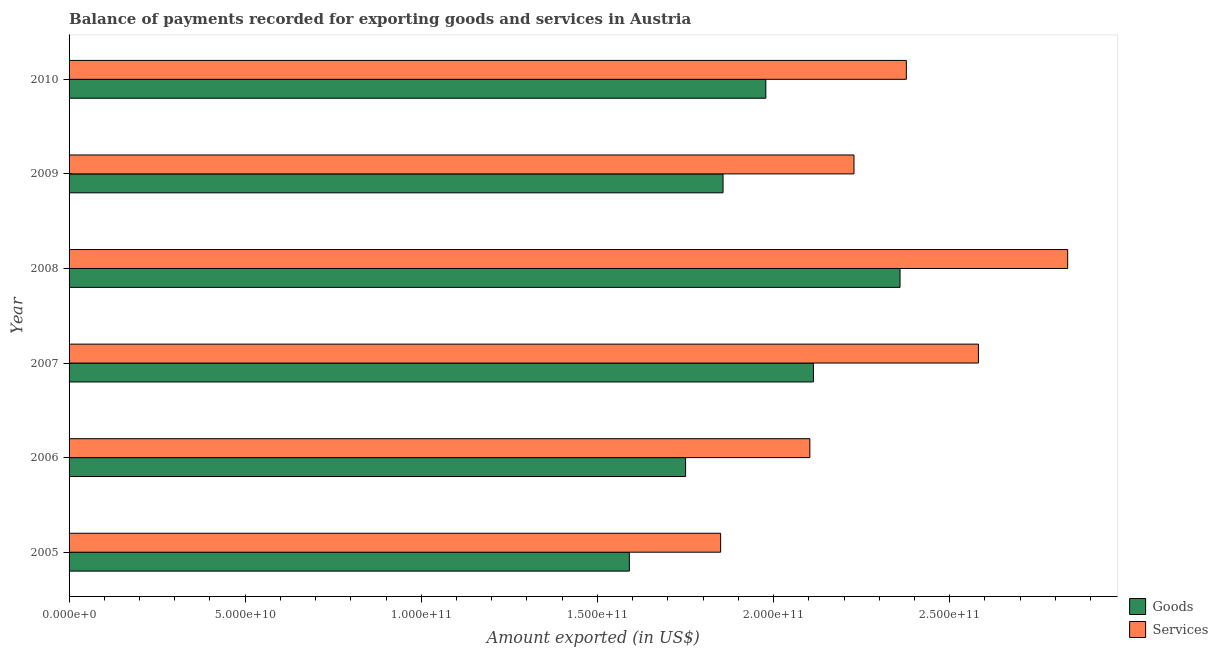How many groups of bars are there?
Provide a succinct answer. 6. Are the number of bars on each tick of the Y-axis equal?
Ensure brevity in your answer.  Yes. How many bars are there on the 2nd tick from the top?
Provide a succinct answer. 2. How many bars are there on the 2nd tick from the bottom?
Your answer should be compact. 2. What is the label of the 4th group of bars from the top?
Your answer should be very brief. 2007. What is the amount of services exported in 2005?
Your answer should be compact. 1.85e+11. Across all years, what is the maximum amount of services exported?
Provide a short and direct response. 2.83e+11. Across all years, what is the minimum amount of goods exported?
Provide a short and direct response. 1.59e+11. In which year was the amount of goods exported maximum?
Provide a succinct answer. 2008. What is the total amount of services exported in the graph?
Your answer should be compact. 1.40e+12. What is the difference between the amount of services exported in 2007 and that in 2008?
Keep it short and to the point. -2.53e+1. What is the difference between the amount of goods exported in 2006 and the amount of services exported in 2007?
Offer a terse response. -8.31e+1. What is the average amount of goods exported per year?
Make the answer very short. 1.94e+11. In the year 2009, what is the difference between the amount of services exported and amount of goods exported?
Provide a short and direct response. 3.72e+1. In how many years, is the amount of goods exported greater than 70000000000 US$?
Provide a short and direct response. 6. What is the ratio of the amount of goods exported in 2005 to that in 2007?
Make the answer very short. 0.75. Is the difference between the amount of goods exported in 2006 and 2008 greater than the difference between the amount of services exported in 2006 and 2008?
Provide a succinct answer. Yes. What is the difference between the highest and the second highest amount of goods exported?
Offer a terse response. 2.46e+1. What is the difference between the highest and the lowest amount of services exported?
Offer a terse response. 9.85e+1. Is the sum of the amount of services exported in 2009 and 2010 greater than the maximum amount of goods exported across all years?
Your answer should be compact. Yes. What does the 1st bar from the top in 2008 represents?
Your response must be concise. Services. What does the 2nd bar from the bottom in 2007 represents?
Your answer should be compact. Services. How many bars are there?
Provide a short and direct response. 12. Are all the bars in the graph horizontal?
Make the answer very short. Yes. How many years are there in the graph?
Keep it short and to the point. 6. What is the difference between two consecutive major ticks on the X-axis?
Offer a terse response. 5.00e+1. Does the graph contain any zero values?
Your answer should be very brief. No. Does the graph contain grids?
Your response must be concise. No. How are the legend labels stacked?
Provide a short and direct response. Vertical. What is the title of the graph?
Your response must be concise. Balance of payments recorded for exporting goods and services in Austria. What is the label or title of the X-axis?
Keep it short and to the point. Amount exported (in US$). What is the label or title of the Y-axis?
Your answer should be compact. Year. What is the Amount exported (in US$) of Goods in 2005?
Make the answer very short. 1.59e+11. What is the Amount exported (in US$) of Services in 2005?
Give a very brief answer. 1.85e+11. What is the Amount exported (in US$) in Goods in 2006?
Offer a terse response. 1.75e+11. What is the Amount exported (in US$) in Services in 2006?
Ensure brevity in your answer.  2.10e+11. What is the Amount exported (in US$) in Goods in 2007?
Your response must be concise. 2.11e+11. What is the Amount exported (in US$) in Services in 2007?
Make the answer very short. 2.58e+11. What is the Amount exported (in US$) of Goods in 2008?
Provide a short and direct response. 2.36e+11. What is the Amount exported (in US$) in Services in 2008?
Your answer should be very brief. 2.83e+11. What is the Amount exported (in US$) in Goods in 2009?
Keep it short and to the point. 1.86e+11. What is the Amount exported (in US$) of Services in 2009?
Your answer should be very brief. 2.23e+11. What is the Amount exported (in US$) in Goods in 2010?
Your response must be concise. 1.98e+11. What is the Amount exported (in US$) in Services in 2010?
Keep it short and to the point. 2.38e+11. Across all years, what is the maximum Amount exported (in US$) of Goods?
Offer a terse response. 2.36e+11. Across all years, what is the maximum Amount exported (in US$) in Services?
Give a very brief answer. 2.83e+11. Across all years, what is the minimum Amount exported (in US$) of Goods?
Keep it short and to the point. 1.59e+11. Across all years, what is the minimum Amount exported (in US$) in Services?
Offer a terse response. 1.85e+11. What is the total Amount exported (in US$) of Goods in the graph?
Make the answer very short. 1.16e+12. What is the total Amount exported (in US$) in Services in the graph?
Your answer should be very brief. 1.40e+12. What is the difference between the Amount exported (in US$) of Goods in 2005 and that in 2006?
Your response must be concise. -1.60e+1. What is the difference between the Amount exported (in US$) of Services in 2005 and that in 2006?
Provide a succinct answer. -2.53e+1. What is the difference between the Amount exported (in US$) of Goods in 2005 and that in 2007?
Ensure brevity in your answer.  -5.23e+1. What is the difference between the Amount exported (in US$) of Services in 2005 and that in 2007?
Make the answer very short. -7.32e+1. What is the difference between the Amount exported (in US$) of Goods in 2005 and that in 2008?
Give a very brief answer. -7.68e+1. What is the difference between the Amount exported (in US$) of Services in 2005 and that in 2008?
Provide a short and direct response. -9.85e+1. What is the difference between the Amount exported (in US$) in Goods in 2005 and that in 2009?
Provide a short and direct response. -2.66e+1. What is the difference between the Amount exported (in US$) in Services in 2005 and that in 2009?
Offer a very short reply. -3.79e+1. What is the difference between the Amount exported (in US$) of Goods in 2005 and that in 2010?
Ensure brevity in your answer.  -3.87e+1. What is the difference between the Amount exported (in US$) in Services in 2005 and that in 2010?
Provide a succinct answer. -5.27e+1. What is the difference between the Amount exported (in US$) of Goods in 2006 and that in 2007?
Provide a short and direct response. -3.63e+1. What is the difference between the Amount exported (in US$) of Services in 2006 and that in 2007?
Your response must be concise. -4.79e+1. What is the difference between the Amount exported (in US$) in Goods in 2006 and that in 2008?
Keep it short and to the point. -6.09e+1. What is the difference between the Amount exported (in US$) in Services in 2006 and that in 2008?
Make the answer very short. -7.32e+1. What is the difference between the Amount exported (in US$) of Goods in 2006 and that in 2009?
Provide a short and direct response. -1.06e+1. What is the difference between the Amount exported (in US$) in Services in 2006 and that in 2009?
Provide a succinct answer. -1.25e+1. What is the difference between the Amount exported (in US$) in Goods in 2006 and that in 2010?
Provide a succinct answer. -2.28e+1. What is the difference between the Amount exported (in US$) in Services in 2006 and that in 2010?
Make the answer very short. -2.74e+1. What is the difference between the Amount exported (in US$) in Goods in 2007 and that in 2008?
Keep it short and to the point. -2.46e+1. What is the difference between the Amount exported (in US$) of Services in 2007 and that in 2008?
Keep it short and to the point. -2.53e+1. What is the difference between the Amount exported (in US$) of Goods in 2007 and that in 2009?
Your response must be concise. 2.57e+1. What is the difference between the Amount exported (in US$) in Services in 2007 and that in 2009?
Your answer should be compact. 3.53e+1. What is the difference between the Amount exported (in US$) of Goods in 2007 and that in 2010?
Make the answer very short. 1.35e+1. What is the difference between the Amount exported (in US$) of Services in 2007 and that in 2010?
Keep it short and to the point. 2.05e+1. What is the difference between the Amount exported (in US$) in Goods in 2008 and that in 2009?
Your response must be concise. 5.02e+1. What is the difference between the Amount exported (in US$) in Services in 2008 and that in 2009?
Give a very brief answer. 6.07e+1. What is the difference between the Amount exported (in US$) in Goods in 2008 and that in 2010?
Your response must be concise. 3.81e+1. What is the difference between the Amount exported (in US$) of Services in 2008 and that in 2010?
Make the answer very short. 4.58e+1. What is the difference between the Amount exported (in US$) of Goods in 2009 and that in 2010?
Your answer should be compact. -1.21e+1. What is the difference between the Amount exported (in US$) in Services in 2009 and that in 2010?
Provide a short and direct response. -1.49e+1. What is the difference between the Amount exported (in US$) in Goods in 2005 and the Amount exported (in US$) in Services in 2006?
Ensure brevity in your answer.  -5.12e+1. What is the difference between the Amount exported (in US$) of Goods in 2005 and the Amount exported (in US$) of Services in 2007?
Your answer should be very brief. -9.91e+1. What is the difference between the Amount exported (in US$) of Goods in 2005 and the Amount exported (in US$) of Services in 2008?
Your response must be concise. -1.24e+11. What is the difference between the Amount exported (in US$) of Goods in 2005 and the Amount exported (in US$) of Services in 2009?
Provide a short and direct response. -6.38e+1. What is the difference between the Amount exported (in US$) of Goods in 2005 and the Amount exported (in US$) of Services in 2010?
Your answer should be compact. -7.86e+1. What is the difference between the Amount exported (in US$) of Goods in 2006 and the Amount exported (in US$) of Services in 2007?
Keep it short and to the point. -8.31e+1. What is the difference between the Amount exported (in US$) in Goods in 2006 and the Amount exported (in US$) in Services in 2008?
Your response must be concise. -1.08e+11. What is the difference between the Amount exported (in US$) in Goods in 2006 and the Amount exported (in US$) in Services in 2009?
Offer a very short reply. -4.78e+1. What is the difference between the Amount exported (in US$) in Goods in 2006 and the Amount exported (in US$) in Services in 2010?
Your response must be concise. -6.27e+1. What is the difference between the Amount exported (in US$) in Goods in 2007 and the Amount exported (in US$) in Services in 2008?
Provide a succinct answer. -7.22e+1. What is the difference between the Amount exported (in US$) of Goods in 2007 and the Amount exported (in US$) of Services in 2009?
Your answer should be compact. -1.15e+1. What is the difference between the Amount exported (in US$) of Goods in 2007 and the Amount exported (in US$) of Services in 2010?
Make the answer very short. -2.64e+1. What is the difference between the Amount exported (in US$) of Goods in 2008 and the Amount exported (in US$) of Services in 2009?
Make the answer very short. 1.31e+1. What is the difference between the Amount exported (in US$) in Goods in 2008 and the Amount exported (in US$) in Services in 2010?
Offer a terse response. -1.79e+09. What is the difference between the Amount exported (in US$) in Goods in 2009 and the Amount exported (in US$) in Services in 2010?
Ensure brevity in your answer.  -5.20e+1. What is the average Amount exported (in US$) in Goods per year?
Ensure brevity in your answer.  1.94e+11. What is the average Amount exported (in US$) in Services per year?
Offer a very short reply. 2.33e+11. In the year 2005, what is the difference between the Amount exported (in US$) of Goods and Amount exported (in US$) of Services?
Offer a terse response. -2.59e+1. In the year 2006, what is the difference between the Amount exported (in US$) of Goods and Amount exported (in US$) of Services?
Your response must be concise. -3.53e+1. In the year 2007, what is the difference between the Amount exported (in US$) of Goods and Amount exported (in US$) of Services?
Keep it short and to the point. -4.68e+1. In the year 2008, what is the difference between the Amount exported (in US$) of Goods and Amount exported (in US$) of Services?
Provide a short and direct response. -4.76e+1. In the year 2009, what is the difference between the Amount exported (in US$) in Goods and Amount exported (in US$) in Services?
Offer a very short reply. -3.72e+1. In the year 2010, what is the difference between the Amount exported (in US$) of Goods and Amount exported (in US$) of Services?
Keep it short and to the point. -3.99e+1. What is the ratio of the Amount exported (in US$) in Goods in 2005 to that in 2006?
Offer a terse response. 0.91. What is the ratio of the Amount exported (in US$) of Services in 2005 to that in 2006?
Make the answer very short. 0.88. What is the ratio of the Amount exported (in US$) in Goods in 2005 to that in 2007?
Your response must be concise. 0.75. What is the ratio of the Amount exported (in US$) in Services in 2005 to that in 2007?
Give a very brief answer. 0.72. What is the ratio of the Amount exported (in US$) of Goods in 2005 to that in 2008?
Your answer should be compact. 0.67. What is the ratio of the Amount exported (in US$) of Services in 2005 to that in 2008?
Provide a succinct answer. 0.65. What is the ratio of the Amount exported (in US$) of Goods in 2005 to that in 2009?
Offer a terse response. 0.86. What is the ratio of the Amount exported (in US$) of Services in 2005 to that in 2009?
Make the answer very short. 0.83. What is the ratio of the Amount exported (in US$) of Goods in 2005 to that in 2010?
Offer a very short reply. 0.8. What is the ratio of the Amount exported (in US$) of Services in 2005 to that in 2010?
Keep it short and to the point. 0.78. What is the ratio of the Amount exported (in US$) of Goods in 2006 to that in 2007?
Your response must be concise. 0.83. What is the ratio of the Amount exported (in US$) of Services in 2006 to that in 2007?
Provide a succinct answer. 0.81. What is the ratio of the Amount exported (in US$) of Goods in 2006 to that in 2008?
Offer a terse response. 0.74. What is the ratio of the Amount exported (in US$) of Services in 2006 to that in 2008?
Give a very brief answer. 0.74. What is the ratio of the Amount exported (in US$) in Goods in 2006 to that in 2009?
Your answer should be compact. 0.94. What is the ratio of the Amount exported (in US$) in Services in 2006 to that in 2009?
Give a very brief answer. 0.94. What is the ratio of the Amount exported (in US$) in Goods in 2006 to that in 2010?
Make the answer very short. 0.88. What is the ratio of the Amount exported (in US$) in Services in 2006 to that in 2010?
Your answer should be very brief. 0.88. What is the ratio of the Amount exported (in US$) of Goods in 2007 to that in 2008?
Give a very brief answer. 0.9. What is the ratio of the Amount exported (in US$) of Services in 2007 to that in 2008?
Offer a terse response. 0.91. What is the ratio of the Amount exported (in US$) in Goods in 2007 to that in 2009?
Your response must be concise. 1.14. What is the ratio of the Amount exported (in US$) in Services in 2007 to that in 2009?
Offer a terse response. 1.16. What is the ratio of the Amount exported (in US$) of Goods in 2007 to that in 2010?
Offer a very short reply. 1.07. What is the ratio of the Amount exported (in US$) of Services in 2007 to that in 2010?
Provide a succinct answer. 1.09. What is the ratio of the Amount exported (in US$) in Goods in 2008 to that in 2009?
Offer a terse response. 1.27. What is the ratio of the Amount exported (in US$) of Services in 2008 to that in 2009?
Give a very brief answer. 1.27. What is the ratio of the Amount exported (in US$) in Goods in 2008 to that in 2010?
Keep it short and to the point. 1.19. What is the ratio of the Amount exported (in US$) of Services in 2008 to that in 2010?
Provide a succinct answer. 1.19. What is the ratio of the Amount exported (in US$) of Goods in 2009 to that in 2010?
Your answer should be very brief. 0.94. What is the ratio of the Amount exported (in US$) of Services in 2009 to that in 2010?
Make the answer very short. 0.94. What is the difference between the highest and the second highest Amount exported (in US$) in Goods?
Your answer should be compact. 2.46e+1. What is the difference between the highest and the second highest Amount exported (in US$) in Services?
Offer a very short reply. 2.53e+1. What is the difference between the highest and the lowest Amount exported (in US$) of Goods?
Your answer should be very brief. 7.68e+1. What is the difference between the highest and the lowest Amount exported (in US$) of Services?
Give a very brief answer. 9.85e+1. 